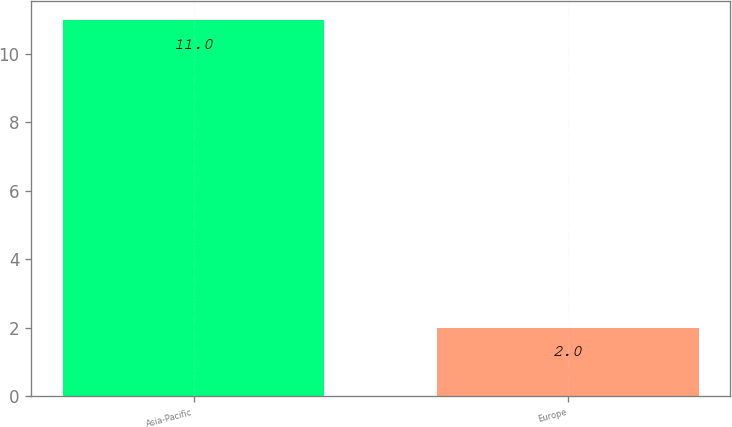Convert chart to OTSL. <chart><loc_0><loc_0><loc_500><loc_500><bar_chart><fcel>Asia-Pacific<fcel>Europe<nl><fcel>11<fcel>2<nl></chart> 